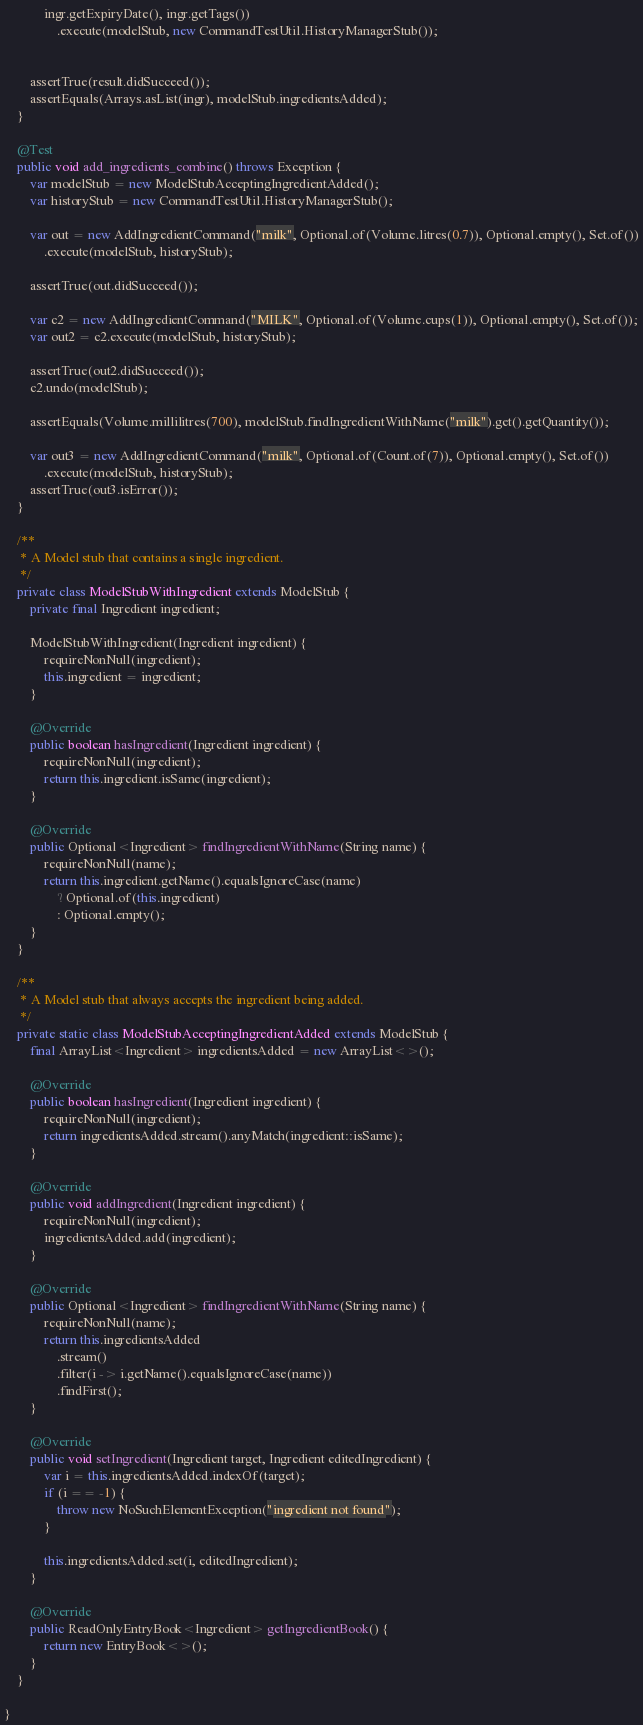Convert code to text. <code><loc_0><loc_0><loc_500><loc_500><_Java_>            ingr.getExpiryDate(), ingr.getTags())
                .execute(modelStub, new CommandTestUtil.HistoryManagerStub());


        assertTrue(result.didSucceed());
        assertEquals(Arrays.asList(ingr), modelStub.ingredientsAdded);
    }

    @Test
    public void add_ingredients_combine() throws Exception {
        var modelStub = new ModelStubAcceptingIngredientAdded();
        var historyStub = new CommandTestUtil.HistoryManagerStub();

        var out = new AddIngredientCommand("milk", Optional.of(Volume.litres(0.7)), Optional.empty(), Set.of())
            .execute(modelStub, historyStub);

        assertTrue(out.didSucceed());

        var c2 = new AddIngredientCommand("MILK", Optional.of(Volume.cups(1)), Optional.empty(), Set.of());
        var out2 = c2.execute(modelStub, historyStub);

        assertTrue(out2.didSucceed());
        c2.undo(modelStub);

        assertEquals(Volume.millilitres(700), modelStub.findIngredientWithName("milk").get().getQuantity());

        var out3 = new AddIngredientCommand("milk", Optional.of(Count.of(7)), Optional.empty(), Set.of())
            .execute(modelStub, historyStub);
        assertTrue(out3.isError());
    }

    /**
     * A Model stub that contains a single ingredient.
     */
    private class ModelStubWithIngredient extends ModelStub {
        private final Ingredient ingredient;

        ModelStubWithIngredient(Ingredient ingredient) {
            requireNonNull(ingredient);
            this.ingredient = ingredient;
        }

        @Override
        public boolean hasIngredient(Ingredient ingredient) {
            requireNonNull(ingredient);
            return this.ingredient.isSame(ingredient);
        }

        @Override
        public Optional<Ingredient> findIngredientWithName(String name) {
            requireNonNull(name);
            return this.ingredient.getName().equalsIgnoreCase(name)
                ? Optional.of(this.ingredient)
                : Optional.empty();
        }
    }

    /**
     * A Model stub that always accepts the ingredient being added.
     */
    private static class ModelStubAcceptingIngredientAdded extends ModelStub {
        final ArrayList<Ingredient> ingredientsAdded = new ArrayList<>();

        @Override
        public boolean hasIngredient(Ingredient ingredient) {
            requireNonNull(ingredient);
            return ingredientsAdded.stream().anyMatch(ingredient::isSame);
        }

        @Override
        public void addIngredient(Ingredient ingredient) {
            requireNonNull(ingredient);
            ingredientsAdded.add(ingredient);
        }

        @Override
        public Optional<Ingredient> findIngredientWithName(String name) {
            requireNonNull(name);
            return this.ingredientsAdded
                .stream()
                .filter(i -> i.getName().equalsIgnoreCase(name))
                .findFirst();
        }

        @Override
        public void setIngredient(Ingredient target, Ingredient editedIngredient) {
            var i = this.ingredientsAdded.indexOf(target);
            if (i == -1) {
                throw new NoSuchElementException("ingredient not found");
            }

            this.ingredientsAdded.set(i, editedIngredient);
        }

        @Override
        public ReadOnlyEntryBook<Ingredient> getIngredientBook() {
            return new EntryBook<>();
        }
    }

}
</code> 